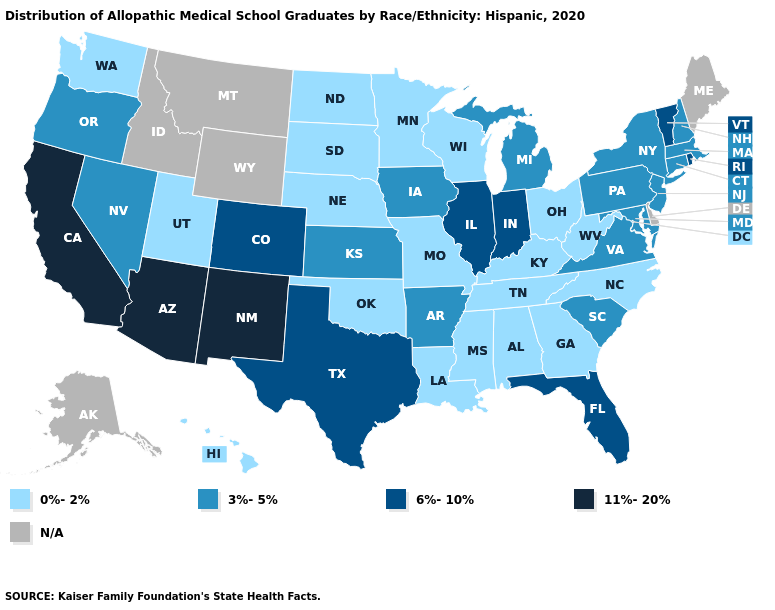Name the states that have a value in the range 0%-2%?
Quick response, please. Alabama, Georgia, Hawaii, Kentucky, Louisiana, Minnesota, Mississippi, Missouri, Nebraska, North Carolina, North Dakota, Ohio, Oklahoma, South Dakota, Tennessee, Utah, Washington, West Virginia, Wisconsin. Does New Mexico have the highest value in the West?
Write a very short answer. Yes. Is the legend a continuous bar?
Answer briefly. No. Among the states that border California , does Arizona have the highest value?
Write a very short answer. Yes. Name the states that have a value in the range 11%-20%?
Keep it brief. Arizona, California, New Mexico. Among the states that border Oregon , which have the highest value?
Concise answer only. California. What is the lowest value in the South?
Keep it brief. 0%-2%. What is the value of Arizona?
Keep it brief. 11%-20%. What is the lowest value in the Northeast?
Answer briefly. 3%-5%. What is the value of New Jersey?
Answer briefly. 3%-5%. Does Florida have the highest value in the South?
Concise answer only. Yes. Which states hav the highest value in the West?
Write a very short answer. Arizona, California, New Mexico. What is the lowest value in the USA?
Write a very short answer. 0%-2%. What is the value of Kansas?
Quick response, please. 3%-5%. What is the value of South Carolina?
Be succinct. 3%-5%. 